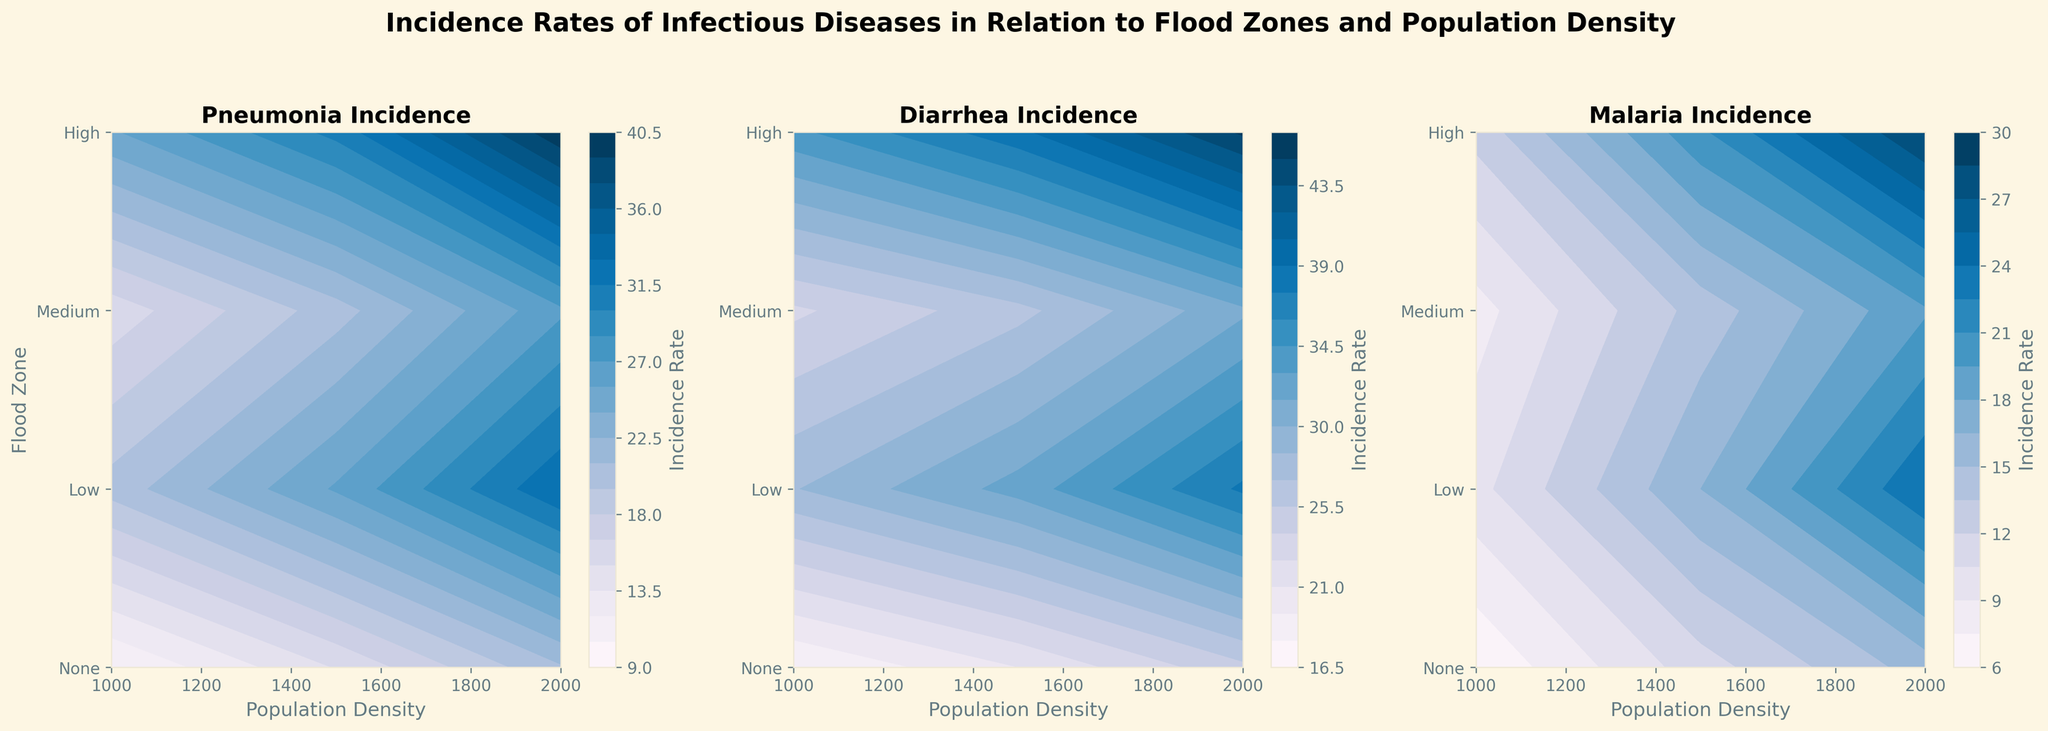What's the overall trend in pneumonia incidence rate as population density increases across all flood zones? In examining the contour plot for pneumonia incidence, it's clear that the incidence rate generally increases with rising population density across all flood zones. This is shown by the increasing values from left to right.
Answer: increases In which flood zone is the incidence of diarrhea highest when the population density is 1500? By examining the contour plot for diarrhea incidence, we see that for a population density of 1500, the highest incidence is found in the "High" flood zone. This is represented by the darkest contour shade at that population density.
Answer: High How does malaria incidence in low flood zones compare to none flood zones at a 2000 population density? Comparing the malaria incidence across the two zones with a population density of 2000, the contour plot indicates higher incidence rates in low flood zones compared to no flood zones. This is inferred by observing the contour levels, which are higher in the low flood zone.
Answer: higher What pattern is observed in the incidence rates of infectious diseases across flood zones when population density is maintained at 1000? From the plots, we can observe a consistent pattern where the incidence rates for pneumonia, diarrhea, and malaria are highest in high flood zones and decrease progressively as the flood risk decreases to none. This is seen by comparing the darkest shades along the 1000 population density line across all disease plots.
Answer: decreases Which infectious disease shows the steepest increase in incidence from medium to high flood zones at a population density of 2000? Referring to the contour plots, the incidence of pneumonia shows the steepest increase moving from medium to high flood zones at the 2000 population density, indicated by the sharp increase in contour levels.
Answer: pneumonia What can be inferred about the relationship between malaria incidence and population density in high flood zones? Observing the contour plot for malaria incidence, it is clear that there is a substantial increase in malaria incidence as population density increases within high flood zones. This is shown by the rising contour levels as population density increases.
Answer: increases Is there any flood zone where diarrhea incidence surpasses pneumonia incidence for any population density? If so, specify the zone and density. The contour plots illustrate that in high flood zones at a population density of 1000, the incidence rate of diarrhea surpasses that of pneumonia. This is shown by comparing the contour levels for the same population density.
Answer: High, 1000 What's the relative difference in malaria incidence between the high flood zone and medium flood zone at a population density of 1500? In the contour plot for malaria incidence, at a density of 1500, the difference between the high and medium flood zones is evident. The incidence rate is markedly higher in high flood zones compared to medium flood zones. Numerically, this can be inferred as approximately 20.7 (high) - 16.5 (medium) = 4.2.
Answer: 4.2 